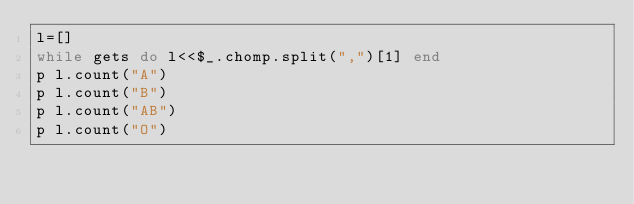<code> <loc_0><loc_0><loc_500><loc_500><_Ruby_>l=[]
while gets do l<<$_.chomp.split(",")[1] end
p l.count("A")
p l.count("B")
p l.count("AB")
p l.count("O")</code> 